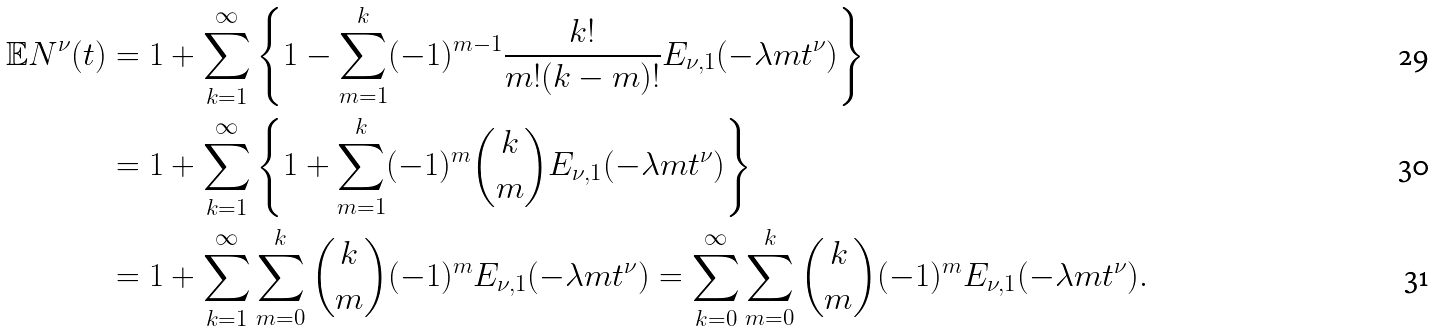<formula> <loc_0><loc_0><loc_500><loc_500>\mathbb { E } N ^ { \nu } ( t ) & = 1 + \sum _ { k = 1 } ^ { \infty } \left \{ 1 - \sum _ { m = 1 } ^ { k } ( - 1 ) ^ { m - 1 } \frac { k ! } { m ! ( k - m ) ! } E _ { \nu , 1 } ( - \lambda m t ^ { \nu } ) \right \} \\ & = 1 + \sum _ { k = 1 } ^ { \infty } \left \{ 1 + \sum _ { m = 1 } ^ { k } ( - 1 ) ^ { m } \binom { k } { m } E _ { \nu , 1 } ( - \lambda m t ^ { \nu } ) \right \} \\ & = 1 + \sum _ { k = 1 } ^ { \infty } \sum _ { m = 0 } ^ { k } \binom { k } { m } ( - 1 ) ^ { m } E _ { \nu , 1 } ( - \lambda m t ^ { \nu } ) = \sum _ { k = 0 } ^ { \infty } \sum _ { m = 0 } ^ { k } \binom { k } { m } ( - 1 ) ^ { m } E _ { \nu , 1 } ( - \lambda m t ^ { \nu } ) .</formula> 